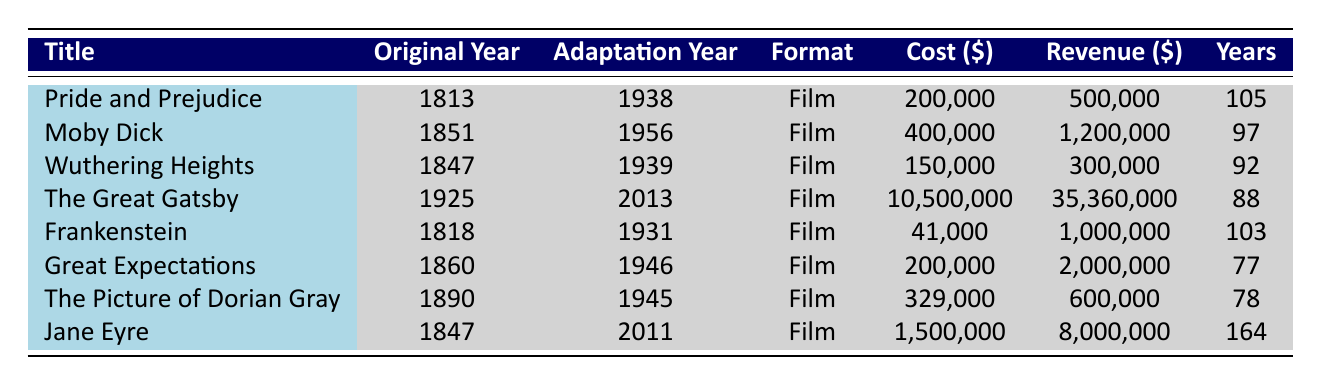What is the adaptation format for "Jane Eyre"? The table shows that "Jane Eyre" was adapted into a Film format.
Answer: Film Which classic literature title had the highest box office revenue? By comparing the box office revenue figures in the table, "The Great Gatsby" has the highest revenue at 35,360,000.
Answer: The Great Gatsby How many years passed between the original publication and the adaptation of "Frankenstein"? The original publication year of "Frankenstein" is 1818, and the adaptation year is 1931. So, the difference is 1931 - 1818 = 113 years.
Answer: 113 Which adaptation had the lowest cost? Looking at the adaptation costs in the table, "Frankenstein" has the lowest adaptation cost at 41,000.
Answer: 41,000 Is "Wuthering Heights" more recent than "The Great Gatsby"? The adaptation year for "Wuthering Heights" is 1939, and for "The Great Gatsby," it is 2013. Since 1939 is earlier than 2013, the statement is false.
Answer: No What is the average adaptation cost for the listed classic literature? The adaptation costs are 200,000, 400,000, 150,000, 10,500,000, 41,000, 200,000, 329,000, and 1,500,000. Sum them up: 200,000 + 400,000 + 150,000 + 10,500,000 + 41,000 + 200,000 + 329,000 + 1,500,000 = 13,820,000. There are 8 adaptations, so the average is 13,820,000 / 8 = 1,727,500.
Answer: 1,727,500 How many adaptations were made within 100 years of the original publication? The adaptations made within 100 years are "Pride and Prejudice" (105 years apart) and "Frankenstein" (113 years apart), which both exceed 100. The others exceed 100 years too, which gives a total of 0 adaptations within 100 years.
Answer: 0 What is the total box office revenue for adaptations after 1950? The adaptations after 1950 are "Moby Dick" (1,200,000), "The Great Gatsby" (35,360,000), and "Jane Eyre" (8,000,000). Summing these gives 1,200,000 + 35,360,000 + 8,000,000 = 44,560,000.
Answer: 44,560,000 